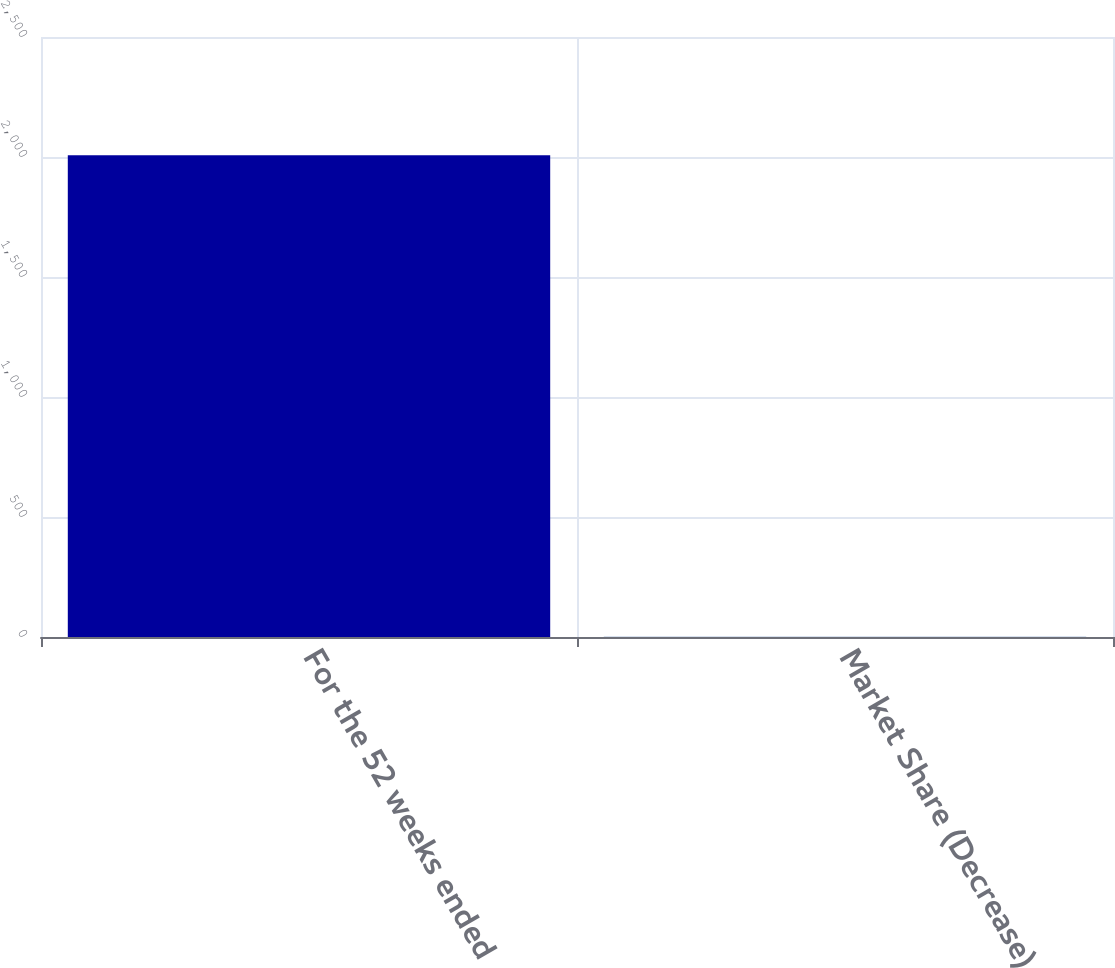Convert chart. <chart><loc_0><loc_0><loc_500><loc_500><bar_chart><fcel>For the 52 weeks ended<fcel>Market Share (Decrease)<nl><fcel>2007<fcel>1.3<nl></chart> 